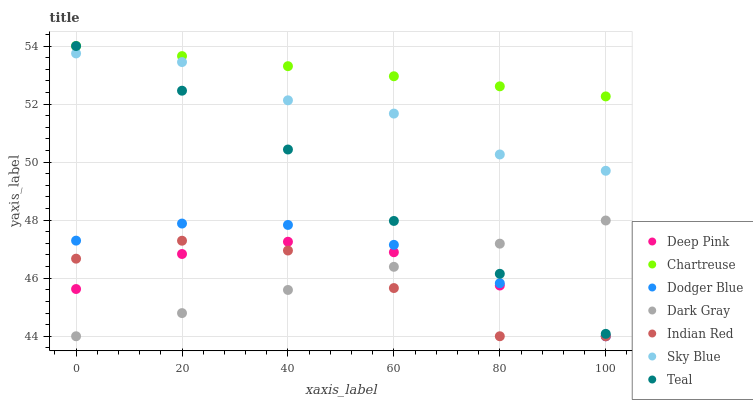Does Indian Red have the minimum area under the curve?
Answer yes or no. Yes. Does Chartreuse have the maximum area under the curve?
Answer yes or no. Yes. Does Teal have the minimum area under the curve?
Answer yes or no. No. Does Teal have the maximum area under the curve?
Answer yes or no. No. Is Dark Gray the smoothest?
Answer yes or no. Yes. Is Indian Red the roughest?
Answer yes or no. Yes. Is Teal the smoothest?
Answer yes or no. No. Is Teal the roughest?
Answer yes or no. No. Does Deep Pink have the lowest value?
Answer yes or no. Yes. Does Teal have the lowest value?
Answer yes or no. No. Does Chartreuse have the highest value?
Answer yes or no. Yes. Does Dark Gray have the highest value?
Answer yes or no. No. Is Dark Gray less than Chartreuse?
Answer yes or no. Yes. Is Teal greater than Indian Red?
Answer yes or no. Yes. Does Deep Pink intersect Dark Gray?
Answer yes or no. Yes. Is Deep Pink less than Dark Gray?
Answer yes or no. No. Is Deep Pink greater than Dark Gray?
Answer yes or no. No. Does Dark Gray intersect Chartreuse?
Answer yes or no. No. 